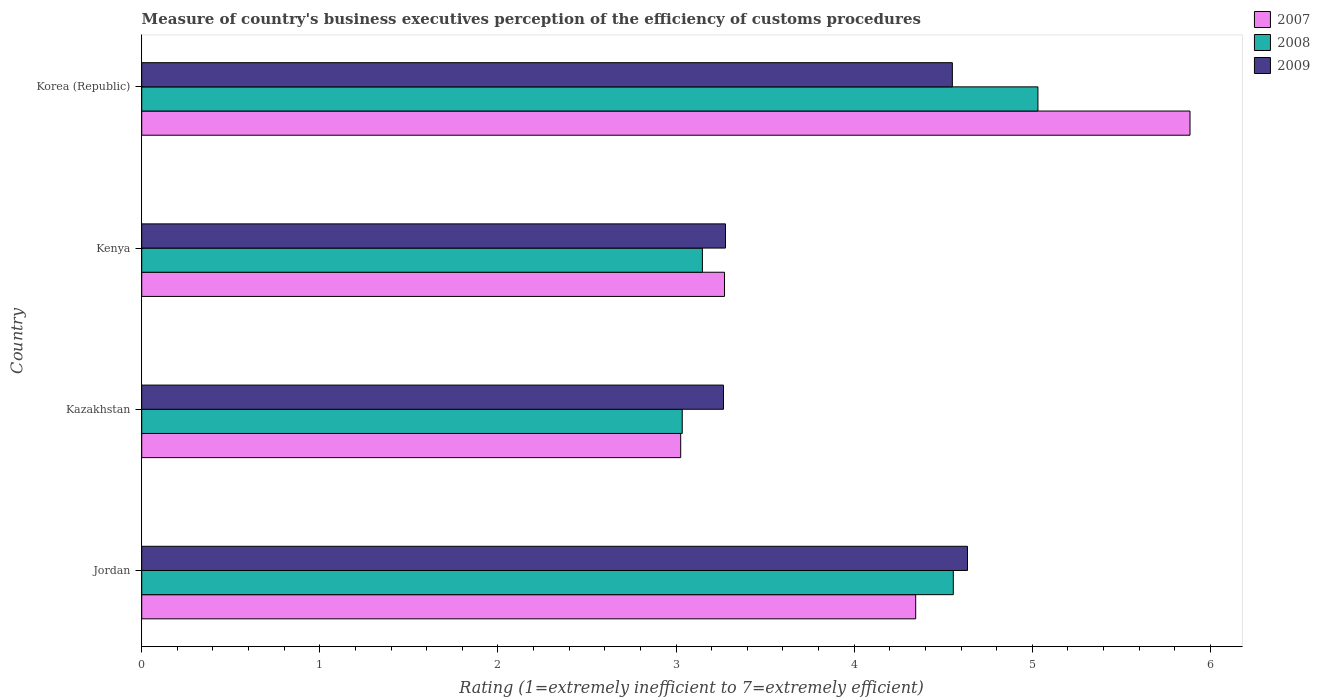How many different coloured bars are there?
Keep it short and to the point. 3. How many groups of bars are there?
Offer a very short reply. 4. Are the number of bars per tick equal to the number of legend labels?
Keep it short and to the point. Yes. How many bars are there on the 4th tick from the top?
Your answer should be very brief. 3. What is the label of the 3rd group of bars from the top?
Offer a terse response. Kazakhstan. What is the rating of the efficiency of customs procedure in 2009 in Kenya?
Provide a succinct answer. 3.28. Across all countries, what is the maximum rating of the efficiency of customs procedure in 2008?
Offer a terse response. 5.03. Across all countries, what is the minimum rating of the efficiency of customs procedure in 2009?
Offer a very short reply. 3.27. In which country was the rating of the efficiency of customs procedure in 2007 maximum?
Offer a very short reply. Korea (Republic). In which country was the rating of the efficiency of customs procedure in 2007 minimum?
Keep it short and to the point. Kazakhstan. What is the total rating of the efficiency of customs procedure in 2009 in the graph?
Your answer should be compact. 15.73. What is the difference between the rating of the efficiency of customs procedure in 2007 in Kenya and that in Korea (Republic)?
Your answer should be compact. -2.61. What is the difference between the rating of the efficiency of customs procedure in 2009 in Jordan and the rating of the efficiency of customs procedure in 2008 in Korea (Republic)?
Your response must be concise. -0.4. What is the average rating of the efficiency of customs procedure in 2008 per country?
Offer a terse response. 3.94. What is the difference between the rating of the efficiency of customs procedure in 2008 and rating of the efficiency of customs procedure in 2007 in Jordan?
Keep it short and to the point. 0.21. In how many countries, is the rating of the efficiency of customs procedure in 2008 greater than 0.8 ?
Your answer should be very brief. 4. What is the ratio of the rating of the efficiency of customs procedure in 2007 in Kazakhstan to that in Kenya?
Your response must be concise. 0.92. Is the difference between the rating of the efficiency of customs procedure in 2008 in Kenya and Korea (Republic) greater than the difference between the rating of the efficiency of customs procedure in 2007 in Kenya and Korea (Republic)?
Keep it short and to the point. Yes. What is the difference between the highest and the second highest rating of the efficiency of customs procedure in 2009?
Your answer should be compact. 0.08. What is the difference between the highest and the lowest rating of the efficiency of customs procedure in 2009?
Your answer should be compact. 1.37. In how many countries, is the rating of the efficiency of customs procedure in 2007 greater than the average rating of the efficiency of customs procedure in 2007 taken over all countries?
Your answer should be compact. 2. What does the 1st bar from the top in Kazakhstan represents?
Ensure brevity in your answer.  2009. What does the 1st bar from the bottom in Korea (Republic) represents?
Ensure brevity in your answer.  2007. How many bars are there?
Provide a short and direct response. 12. Are all the bars in the graph horizontal?
Keep it short and to the point. Yes. How many countries are there in the graph?
Give a very brief answer. 4. What is the difference between two consecutive major ticks on the X-axis?
Provide a succinct answer. 1. Does the graph contain grids?
Offer a very short reply. No. How many legend labels are there?
Give a very brief answer. 3. What is the title of the graph?
Your response must be concise. Measure of country's business executives perception of the efficiency of customs procedures. What is the label or title of the X-axis?
Provide a short and direct response. Rating (1=extremely inefficient to 7=extremely efficient). What is the Rating (1=extremely inefficient to 7=extremely efficient) in 2007 in Jordan?
Ensure brevity in your answer.  4.35. What is the Rating (1=extremely inefficient to 7=extremely efficient) of 2008 in Jordan?
Give a very brief answer. 4.56. What is the Rating (1=extremely inefficient to 7=extremely efficient) in 2009 in Jordan?
Give a very brief answer. 4.64. What is the Rating (1=extremely inefficient to 7=extremely efficient) of 2007 in Kazakhstan?
Offer a terse response. 3.03. What is the Rating (1=extremely inefficient to 7=extremely efficient) of 2008 in Kazakhstan?
Your answer should be compact. 3.03. What is the Rating (1=extremely inefficient to 7=extremely efficient) of 2009 in Kazakhstan?
Offer a very short reply. 3.27. What is the Rating (1=extremely inefficient to 7=extremely efficient) in 2007 in Kenya?
Your answer should be very brief. 3.27. What is the Rating (1=extremely inefficient to 7=extremely efficient) in 2008 in Kenya?
Provide a succinct answer. 3.15. What is the Rating (1=extremely inefficient to 7=extremely efficient) in 2009 in Kenya?
Provide a short and direct response. 3.28. What is the Rating (1=extremely inefficient to 7=extremely efficient) in 2007 in Korea (Republic)?
Your answer should be very brief. 5.89. What is the Rating (1=extremely inefficient to 7=extremely efficient) in 2008 in Korea (Republic)?
Your response must be concise. 5.03. What is the Rating (1=extremely inefficient to 7=extremely efficient) of 2009 in Korea (Republic)?
Provide a succinct answer. 4.55. Across all countries, what is the maximum Rating (1=extremely inefficient to 7=extremely efficient) of 2007?
Your answer should be compact. 5.89. Across all countries, what is the maximum Rating (1=extremely inefficient to 7=extremely efficient) in 2008?
Your answer should be very brief. 5.03. Across all countries, what is the maximum Rating (1=extremely inefficient to 7=extremely efficient) in 2009?
Offer a very short reply. 4.64. Across all countries, what is the minimum Rating (1=extremely inefficient to 7=extremely efficient) in 2007?
Your answer should be very brief. 3.03. Across all countries, what is the minimum Rating (1=extremely inefficient to 7=extremely efficient) of 2008?
Provide a succinct answer. 3.03. Across all countries, what is the minimum Rating (1=extremely inefficient to 7=extremely efficient) in 2009?
Keep it short and to the point. 3.27. What is the total Rating (1=extremely inefficient to 7=extremely efficient) of 2007 in the graph?
Your answer should be very brief. 16.53. What is the total Rating (1=extremely inefficient to 7=extremely efficient) of 2008 in the graph?
Provide a succinct answer. 15.77. What is the total Rating (1=extremely inefficient to 7=extremely efficient) in 2009 in the graph?
Give a very brief answer. 15.73. What is the difference between the Rating (1=extremely inefficient to 7=extremely efficient) in 2007 in Jordan and that in Kazakhstan?
Provide a short and direct response. 1.32. What is the difference between the Rating (1=extremely inefficient to 7=extremely efficient) of 2008 in Jordan and that in Kazakhstan?
Provide a short and direct response. 1.52. What is the difference between the Rating (1=extremely inefficient to 7=extremely efficient) in 2009 in Jordan and that in Kazakhstan?
Keep it short and to the point. 1.37. What is the difference between the Rating (1=extremely inefficient to 7=extremely efficient) of 2007 in Jordan and that in Kenya?
Make the answer very short. 1.07. What is the difference between the Rating (1=extremely inefficient to 7=extremely efficient) in 2008 in Jordan and that in Kenya?
Make the answer very short. 1.41. What is the difference between the Rating (1=extremely inefficient to 7=extremely efficient) of 2009 in Jordan and that in Kenya?
Your answer should be compact. 1.36. What is the difference between the Rating (1=extremely inefficient to 7=extremely efficient) of 2007 in Jordan and that in Korea (Republic)?
Give a very brief answer. -1.54. What is the difference between the Rating (1=extremely inefficient to 7=extremely efficient) of 2008 in Jordan and that in Korea (Republic)?
Your answer should be very brief. -0.48. What is the difference between the Rating (1=extremely inefficient to 7=extremely efficient) of 2009 in Jordan and that in Korea (Republic)?
Your response must be concise. 0.08. What is the difference between the Rating (1=extremely inefficient to 7=extremely efficient) in 2007 in Kazakhstan and that in Kenya?
Your answer should be very brief. -0.25. What is the difference between the Rating (1=extremely inefficient to 7=extremely efficient) of 2008 in Kazakhstan and that in Kenya?
Your answer should be very brief. -0.11. What is the difference between the Rating (1=extremely inefficient to 7=extremely efficient) in 2009 in Kazakhstan and that in Kenya?
Offer a very short reply. -0.01. What is the difference between the Rating (1=extremely inefficient to 7=extremely efficient) in 2007 in Kazakhstan and that in Korea (Republic)?
Give a very brief answer. -2.86. What is the difference between the Rating (1=extremely inefficient to 7=extremely efficient) in 2008 in Kazakhstan and that in Korea (Republic)?
Offer a very short reply. -2. What is the difference between the Rating (1=extremely inefficient to 7=extremely efficient) in 2009 in Kazakhstan and that in Korea (Republic)?
Your response must be concise. -1.28. What is the difference between the Rating (1=extremely inefficient to 7=extremely efficient) in 2007 in Kenya and that in Korea (Republic)?
Your answer should be compact. -2.61. What is the difference between the Rating (1=extremely inefficient to 7=extremely efficient) in 2008 in Kenya and that in Korea (Republic)?
Ensure brevity in your answer.  -1.88. What is the difference between the Rating (1=extremely inefficient to 7=extremely efficient) of 2009 in Kenya and that in Korea (Republic)?
Offer a very short reply. -1.27. What is the difference between the Rating (1=extremely inefficient to 7=extremely efficient) in 2007 in Jordan and the Rating (1=extremely inefficient to 7=extremely efficient) in 2008 in Kazakhstan?
Provide a succinct answer. 1.31. What is the difference between the Rating (1=extremely inefficient to 7=extremely efficient) in 2007 in Jordan and the Rating (1=extremely inefficient to 7=extremely efficient) in 2009 in Kazakhstan?
Your answer should be compact. 1.08. What is the difference between the Rating (1=extremely inefficient to 7=extremely efficient) in 2008 in Jordan and the Rating (1=extremely inefficient to 7=extremely efficient) in 2009 in Kazakhstan?
Offer a very short reply. 1.29. What is the difference between the Rating (1=extremely inefficient to 7=extremely efficient) of 2007 in Jordan and the Rating (1=extremely inefficient to 7=extremely efficient) of 2008 in Kenya?
Provide a succinct answer. 1.2. What is the difference between the Rating (1=extremely inefficient to 7=extremely efficient) in 2007 in Jordan and the Rating (1=extremely inefficient to 7=extremely efficient) in 2009 in Kenya?
Your response must be concise. 1.07. What is the difference between the Rating (1=extremely inefficient to 7=extremely efficient) of 2008 in Jordan and the Rating (1=extremely inefficient to 7=extremely efficient) of 2009 in Kenya?
Give a very brief answer. 1.28. What is the difference between the Rating (1=extremely inefficient to 7=extremely efficient) of 2007 in Jordan and the Rating (1=extremely inefficient to 7=extremely efficient) of 2008 in Korea (Republic)?
Provide a short and direct response. -0.69. What is the difference between the Rating (1=extremely inefficient to 7=extremely efficient) of 2007 in Jordan and the Rating (1=extremely inefficient to 7=extremely efficient) of 2009 in Korea (Republic)?
Ensure brevity in your answer.  -0.21. What is the difference between the Rating (1=extremely inefficient to 7=extremely efficient) in 2008 in Jordan and the Rating (1=extremely inefficient to 7=extremely efficient) in 2009 in Korea (Republic)?
Give a very brief answer. 0.01. What is the difference between the Rating (1=extremely inefficient to 7=extremely efficient) in 2007 in Kazakhstan and the Rating (1=extremely inefficient to 7=extremely efficient) in 2008 in Kenya?
Ensure brevity in your answer.  -0.12. What is the difference between the Rating (1=extremely inefficient to 7=extremely efficient) in 2007 in Kazakhstan and the Rating (1=extremely inefficient to 7=extremely efficient) in 2009 in Kenya?
Your answer should be very brief. -0.25. What is the difference between the Rating (1=extremely inefficient to 7=extremely efficient) in 2008 in Kazakhstan and the Rating (1=extremely inefficient to 7=extremely efficient) in 2009 in Kenya?
Give a very brief answer. -0.24. What is the difference between the Rating (1=extremely inefficient to 7=extremely efficient) in 2007 in Kazakhstan and the Rating (1=extremely inefficient to 7=extremely efficient) in 2008 in Korea (Republic)?
Your answer should be very brief. -2.01. What is the difference between the Rating (1=extremely inefficient to 7=extremely efficient) in 2007 in Kazakhstan and the Rating (1=extremely inefficient to 7=extremely efficient) in 2009 in Korea (Republic)?
Your answer should be very brief. -1.53. What is the difference between the Rating (1=extremely inefficient to 7=extremely efficient) of 2008 in Kazakhstan and the Rating (1=extremely inefficient to 7=extremely efficient) of 2009 in Korea (Republic)?
Make the answer very short. -1.52. What is the difference between the Rating (1=extremely inefficient to 7=extremely efficient) in 2007 in Kenya and the Rating (1=extremely inefficient to 7=extremely efficient) in 2008 in Korea (Republic)?
Your response must be concise. -1.76. What is the difference between the Rating (1=extremely inefficient to 7=extremely efficient) in 2007 in Kenya and the Rating (1=extremely inefficient to 7=extremely efficient) in 2009 in Korea (Republic)?
Your response must be concise. -1.28. What is the difference between the Rating (1=extremely inefficient to 7=extremely efficient) of 2008 in Kenya and the Rating (1=extremely inefficient to 7=extremely efficient) of 2009 in Korea (Republic)?
Provide a succinct answer. -1.4. What is the average Rating (1=extremely inefficient to 7=extremely efficient) in 2007 per country?
Offer a very short reply. 4.13. What is the average Rating (1=extremely inefficient to 7=extremely efficient) in 2008 per country?
Provide a succinct answer. 3.94. What is the average Rating (1=extremely inefficient to 7=extremely efficient) of 2009 per country?
Ensure brevity in your answer.  3.93. What is the difference between the Rating (1=extremely inefficient to 7=extremely efficient) of 2007 and Rating (1=extremely inefficient to 7=extremely efficient) of 2008 in Jordan?
Your answer should be very brief. -0.21. What is the difference between the Rating (1=extremely inefficient to 7=extremely efficient) in 2007 and Rating (1=extremely inefficient to 7=extremely efficient) in 2009 in Jordan?
Offer a terse response. -0.29. What is the difference between the Rating (1=extremely inefficient to 7=extremely efficient) in 2008 and Rating (1=extremely inefficient to 7=extremely efficient) in 2009 in Jordan?
Give a very brief answer. -0.08. What is the difference between the Rating (1=extremely inefficient to 7=extremely efficient) in 2007 and Rating (1=extremely inefficient to 7=extremely efficient) in 2008 in Kazakhstan?
Keep it short and to the point. -0.01. What is the difference between the Rating (1=extremely inefficient to 7=extremely efficient) in 2007 and Rating (1=extremely inefficient to 7=extremely efficient) in 2009 in Kazakhstan?
Offer a very short reply. -0.24. What is the difference between the Rating (1=extremely inefficient to 7=extremely efficient) in 2008 and Rating (1=extremely inefficient to 7=extremely efficient) in 2009 in Kazakhstan?
Offer a very short reply. -0.23. What is the difference between the Rating (1=extremely inefficient to 7=extremely efficient) of 2007 and Rating (1=extremely inefficient to 7=extremely efficient) of 2008 in Kenya?
Offer a terse response. 0.12. What is the difference between the Rating (1=extremely inefficient to 7=extremely efficient) of 2007 and Rating (1=extremely inefficient to 7=extremely efficient) of 2009 in Kenya?
Your answer should be compact. -0.01. What is the difference between the Rating (1=extremely inefficient to 7=extremely efficient) in 2008 and Rating (1=extremely inefficient to 7=extremely efficient) in 2009 in Kenya?
Your answer should be compact. -0.13. What is the difference between the Rating (1=extremely inefficient to 7=extremely efficient) in 2007 and Rating (1=extremely inefficient to 7=extremely efficient) in 2008 in Korea (Republic)?
Provide a short and direct response. 0.85. What is the difference between the Rating (1=extremely inefficient to 7=extremely efficient) of 2007 and Rating (1=extremely inefficient to 7=extremely efficient) of 2009 in Korea (Republic)?
Provide a short and direct response. 1.33. What is the difference between the Rating (1=extremely inefficient to 7=extremely efficient) in 2008 and Rating (1=extremely inefficient to 7=extremely efficient) in 2009 in Korea (Republic)?
Provide a succinct answer. 0.48. What is the ratio of the Rating (1=extremely inefficient to 7=extremely efficient) in 2007 in Jordan to that in Kazakhstan?
Ensure brevity in your answer.  1.44. What is the ratio of the Rating (1=extremely inefficient to 7=extremely efficient) of 2008 in Jordan to that in Kazakhstan?
Provide a succinct answer. 1.5. What is the ratio of the Rating (1=extremely inefficient to 7=extremely efficient) of 2009 in Jordan to that in Kazakhstan?
Make the answer very short. 1.42. What is the ratio of the Rating (1=extremely inefficient to 7=extremely efficient) in 2007 in Jordan to that in Kenya?
Your answer should be compact. 1.33. What is the ratio of the Rating (1=extremely inefficient to 7=extremely efficient) in 2008 in Jordan to that in Kenya?
Your answer should be very brief. 1.45. What is the ratio of the Rating (1=extremely inefficient to 7=extremely efficient) of 2009 in Jordan to that in Kenya?
Your answer should be compact. 1.41. What is the ratio of the Rating (1=extremely inefficient to 7=extremely efficient) of 2007 in Jordan to that in Korea (Republic)?
Your answer should be compact. 0.74. What is the ratio of the Rating (1=extremely inefficient to 7=extremely efficient) of 2008 in Jordan to that in Korea (Republic)?
Make the answer very short. 0.91. What is the ratio of the Rating (1=extremely inefficient to 7=extremely efficient) of 2009 in Jordan to that in Korea (Republic)?
Your answer should be compact. 1.02. What is the ratio of the Rating (1=extremely inefficient to 7=extremely efficient) in 2007 in Kazakhstan to that in Kenya?
Give a very brief answer. 0.92. What is the ratio of the Rating (1=extremely inefficient to 7=extremely efficient) of 2008 in Kazakhstan to that in Kenya?
Offer a very short reply. 0.96. What is the ratio of the Rating (1=extremely inefficient to 7=extremely efficient) of 2009 in Kazakhstan to that in Kenya?
Ensure brevity in your answer.  1. What is the ratio of the Rating (1=extremely inefficient to 7=extremely efficient) in 2007 in Kazakhstan to that in Korea (Republic)?
Provide a succinct answer. 0.51. What is the ratio of the Rating (1=extremely inefficient to 7=extremely efficient) in 2008 in Kazakhstan to that in Korea (Republic)?
Ensure brevity in your answer.  0.6. What is the ratio of the Rating (1=extremely inefficient to 7=extremely efficient) in 2009 in Kazakhstan to that in Korea (Republic)?
Provide a succinct answer. 0.72. What is the ratio of the Rating (1=extremely inefficient to 7=extremely efficient) in 2007 in Kenya to that in Korea (Republic)?
Your response must be concise. 0.56. What is the ratio of the Rating (1=extremely inefficient to 7=extremely efficient) of 2008 in Kenya to that in Korea (Republic)?
Your response must be concise. 0.63. What is the ratio of the Rating (1=extremely inefficient to 7=extremely efficient) in 2009 in Kenya to that in Korea (Republic)?
Your answer should be compact. 0.72. What is the difference between the highest and the second highest Rating (1=extremely inefficient to 7=extremely efficient) of 2007?
Provide a short and direct response. 1.54. What is the difference between the highest and the second highest Rating (1=extremely inefficient to 7=extremely efficient) of 2008?
Ensure brevity in your answer.  0.48. What is the difference between the highest and the second highest Rating (1=extremely inefficient to 7=extremely efficient) of 2009?
Your response must be concise. 0.08. What is the difference between the highest and the lowest Rating (1=extremely inefficient to 7=extremely efficient) in 2007?
Make the answer very short. 2.86. What is the difference between the highest and the lowest Rating (1=extremely inefficient to 7=extremely efficient) in 2008?
Provide a short and direct response. 2. What is the difference between the highest and the lowest Rating (1=extremely inefficient to 7=extremely efficient) of 2009?
Your response must be concise. 1.37. 